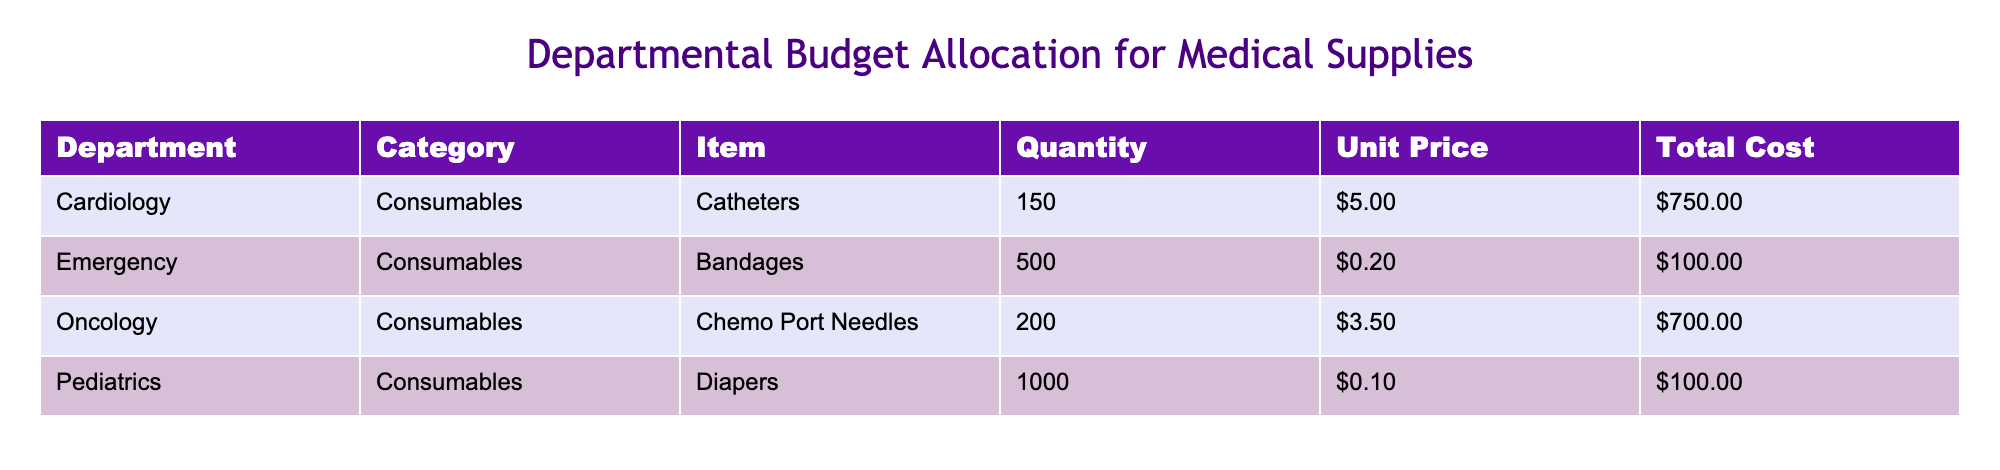What is the total cost of the items in the Cardiology department? The total cost of items in the Cardiology department is directly stated in the table. For the Cardiology department, the total cost is listed as $750.00.
Answer: $750.00 How many Catheters are allocated in the budget? The quantity of Catheters allocated in the budget can be found in the table for the Cardiology department. The table shows that there are 150 Catheters allocated.
Answer: 150 What is the total number of consumables allocated across all departments? To find the total number of consumables, I sum the quantities from each department: 150 (Catheters) + 500 (Bandages) + 200 (Chemo Port Needles) + 1000 (Diapers) = 1850.
Answer: 1850 Which department has the highest total cost for consumables? To determine which department has the highest total cost, I compare the total costs listed for each department: Cardiology is $750.00, Emergency is $100.00, Oncology is $700.00, and Pediatrics is $100.00. Cardiology has the highest total cost at $750.00.
Answer: Cardiology Is the unit price of Diapers less than $0.15? The unit price of Diapers, as listed in the table, is $0.10. Since $0.10 is less than $0.15, the answer is yes.
Answer: Yes What is the average unit price of consumables across all departments? First, I find the unit prices from each department: $5.00 (Catheters), $0.20 (Bandages), $3.50 (Chemo Port Needles), and $0.10 (Diapers). The average unit price is calculated as follows: (5.00 + 0.20 + 3.50 + 0.10) / 4 = 2.95.
Answer: $2.95 If the quantity of Bandages were doubled, what would be the new total cost for that item? The current quantity of Bandages is 500, and the unit price is $0.20. If doubled, the new quantity becomes 1000. To find the new total cost, I multiply this quantity by the unit price: 1000 * $0.20 = $200.00.
Answer: $200.00 Is the total cost of Chemo Port Needles greater than that of Bandages? The total cost of Chemo Port Needles is $700.00, while the total cost of Bandages is $100.00. Since $700.00 is greater than $100.00, the answer is yes.
Answer: Yes 